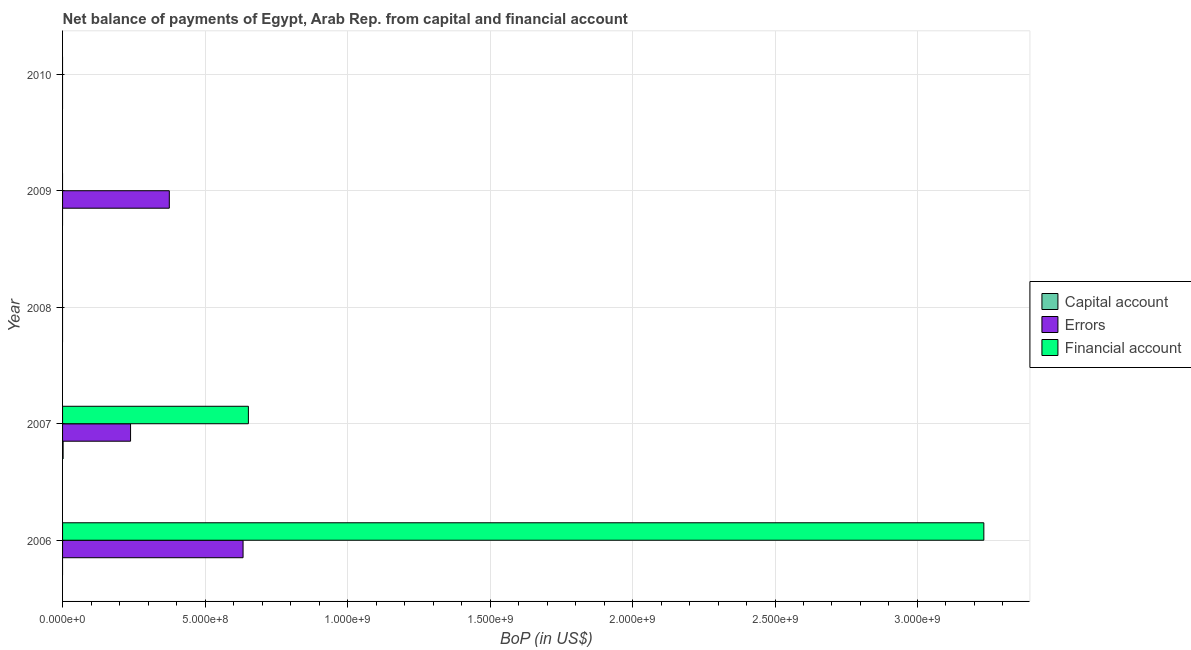Are the number of bars on each tick of the Y-axis equal?
Provide a succinct answer. No. What is the amount of errors in 2007?
Make the answer very short. 2.39e+08. Across all years, what is the maximum amount of errors?
Your answer should be compact. 6.33e+08. What is the total amount of financial account in the graph?
Ensure brevity in your answer.  3.88e+09. What is the difference between the amount of errors in 2006 and the amount of net capital account in 2007?
Make the answer very short. 6.32e+08. What is the average amount of net capital account per year?
Your answer should be compact. 3.80e+05. What is the difference between the highest and the second highest amount of errors?
Provide a succinct answer. 2.59e+08. What is the difference between the highest and the lowest amount of errors?
Your response must be concise. 6.33e+08. How many bars are there?
Your answer should be compact. 6. Are all the bars in the graph horizontal?
Provide a succinct answer. Yes. Are the values on the major ticks of X-axis written in scientific E-notation?
Give a very brief answer. Yes. Does the graph contain grids?
Provide a short and direct response. Yes. How many legend labels are there?
Provide a succinct answer. 3. How are the legend labels stacked?
Offer a very short reply. Vertical. What is the title of the graph?
Keep it short and to the point. Net balance of payments of Egypt, Arab Rep. from capital and financial account. Does "Resident buildings and public services" appear as one of the legend labels in the graph?
Ensure brevity in your answer.  No. What is the label or title of the X-axis?
Ensure brevity in your answer.  BoP (in US$). What is the label or title of the Y-axis?
Give a very brief answer. Year. What is the BoP (in US$) of Errors in 2006?
Your response must be concise. 6.33e+08. What is the BoP (in US$) in Financial account in 2006?
Provide a short and direct response. 3.23e+09. What is the BoP (in US$) in Capital account in 2007?
Your answer should be very brief. 1.90e+06. What is the BoP (in US$) of Errors in 2007?
Provide a succinct answer. 2.39e+08. What is the BoP (in US$) of Financial account in 2007?
Your answer should be very brief. 6.52e+08. What is the BoP (in US$) in Capital account in 2008?
Your response must be concise. 0. What is the BoP (in US$) in Errors in 2008?
Offer a terse response. 0. What is the BoP (in US$) in Capital account in 2009?
Provide a succinct answer. 0. What is the BoP (in US$) in Errors in 2009?
Offer a terse response. 3.75e+08. What is the BoP (in US$) in Capital account in 2010?
Give a very brief answer. 0. Across all years, what is the maximum BoP (in US$) in Capital account?
Keep it short and to the point. 1.90e+06. Across all years, what is the maximum BoP (in US$) in Errors?
Ensure brevity in your answer.  6.33e+08. Across all years, what is the maximum BoP (in US$) of Financial account?
Your answer should be very brief. 3.23e+09. Across all years, what is the minimum BoP (in US$) in Capital account?
Provide a succinct answer. 0. What is the total BoP (in US$) of Capital account in the graph?
Ensure brevity in your answer.  1.90e+06. What is the total BoP (in US$) in Errors in the graph?
Provide a short and direct response. 1.25e+09. What is the total BoP (in US$) of Financial account in the graph?
Offer a very short reply. 3.88e+09. What is the difference between the BoP (in US$) of Errors in 2006 and that in 2007?
Offer a very short reply. 3.95e+08. What is the difference between the BoP (in US$) of Financial account in 2006 and that in 2007?
Provide a succinct answer. 2.58e+09. What is the difference between the BoP (in US$) of Errors in 2006 and that in 2009?
Your response must be concise. 2.59e+08. What is the difference between the BoP (in US$) in Errors in 2007 and that in 2009?
Keep it short and to the point. -1.36e+08. What is the difference between the BoP (in US$) of Errors in 2006 and the BoP (in US$) of Financial account in 2007?
Give a very brief answer. -1.87e+07. What is the difference between the BoP (in US$) of Capital account in 2007 and the BoP (in US$) of Errors in 2009?
Make the answer very short. -3.73e+08. What is the average BoP (in US$) in Errors per year?
Provide a succinct answer. 2.49e+08. What is the average BoP (in US$) in Financial account per year?
Keep it short and to the point. 7.77e+08. In the year 2006, what is the difference between the BoP (in US$) of Errors and BoP (in US$) of Financial account?
Give a very brief answer. -2.60e+09. In the year 2007, what is the difference between the BoP (in US$) in Capital account and BoP (in US$) in Errors?
Provide a succinct answer. -2.37e+08. In the year 2007, what is the difference between the BoP (in US$) of Capital account and BoP (in US$) of Financial account?
Make the answer very short. -6.50e+08. In the year 2007, what is the difference between the BoP (in US$) in Errors and BoP (in US$) in Financial account?
Ensure brevity in your answer.  -4.14e+08. What is the ratio of the BoP (in US$) of Errors in 2006 to that in 2007?
Your answer should be very brief. 2.65. What is the ratio of the BoP (in US$) in Financial account in 2006 to that in 2007?
Give a very brief answer. 4.96. What is the ratio of the BoP (in US$) in Errors in 2006 to that in 2009?
Provide a short and direct response. 1.69. What is the ratio of the BoP (in US$) in Errors in 2007 to that in 2009?
Your answer should be compact. 0.64. What is the difference between the highest and the second highest BoP (in US$) in Errors?
Make the answer very short. 2.59e+08. What is the difference between the highest and the lowest BoP (in US$) of Capital account?
Ensure brevity in your answer.  1.90e+06. What is the difference between the highest and the lowest BoP (in US$) in Errors?
Your answer should be compact. 6.33e+08. What is the difference between the highest and the lowest BoP (in US$) of Financial account?
Make the answer very short. 3.23e+09. 